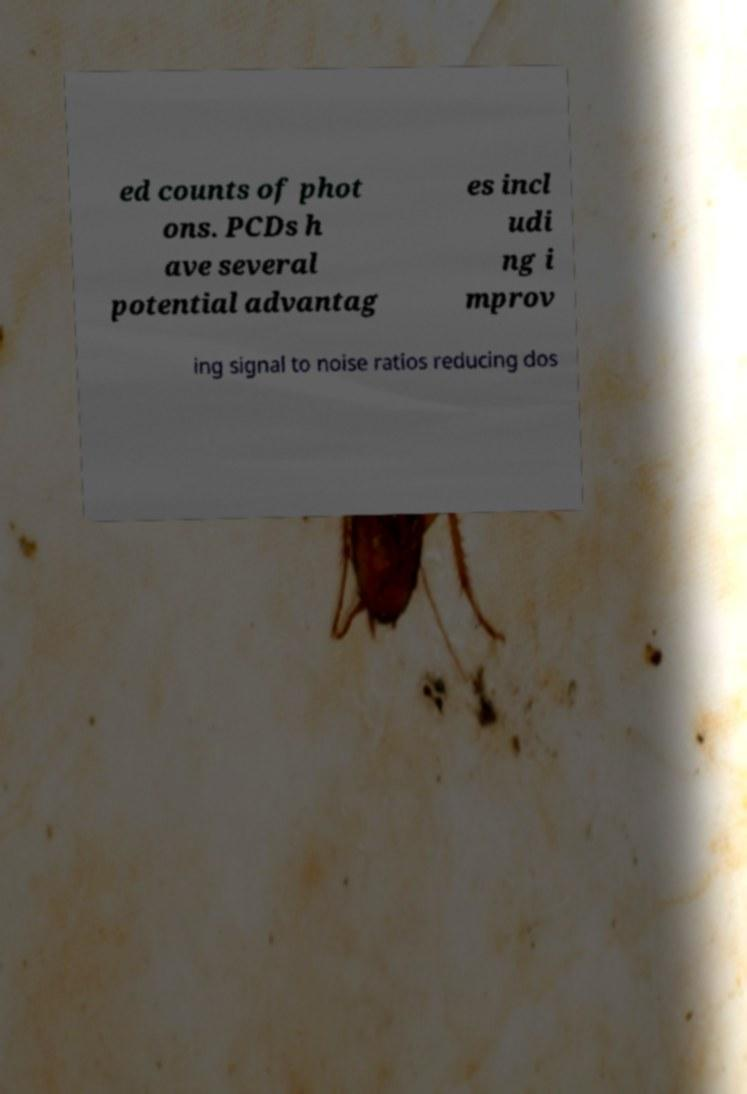Could you extract and type out the text from this image? ed counts of phot ons. PCDs h ave several potential advantag es incl udi ng i mprov ing signal to noise ratios reducing dos 